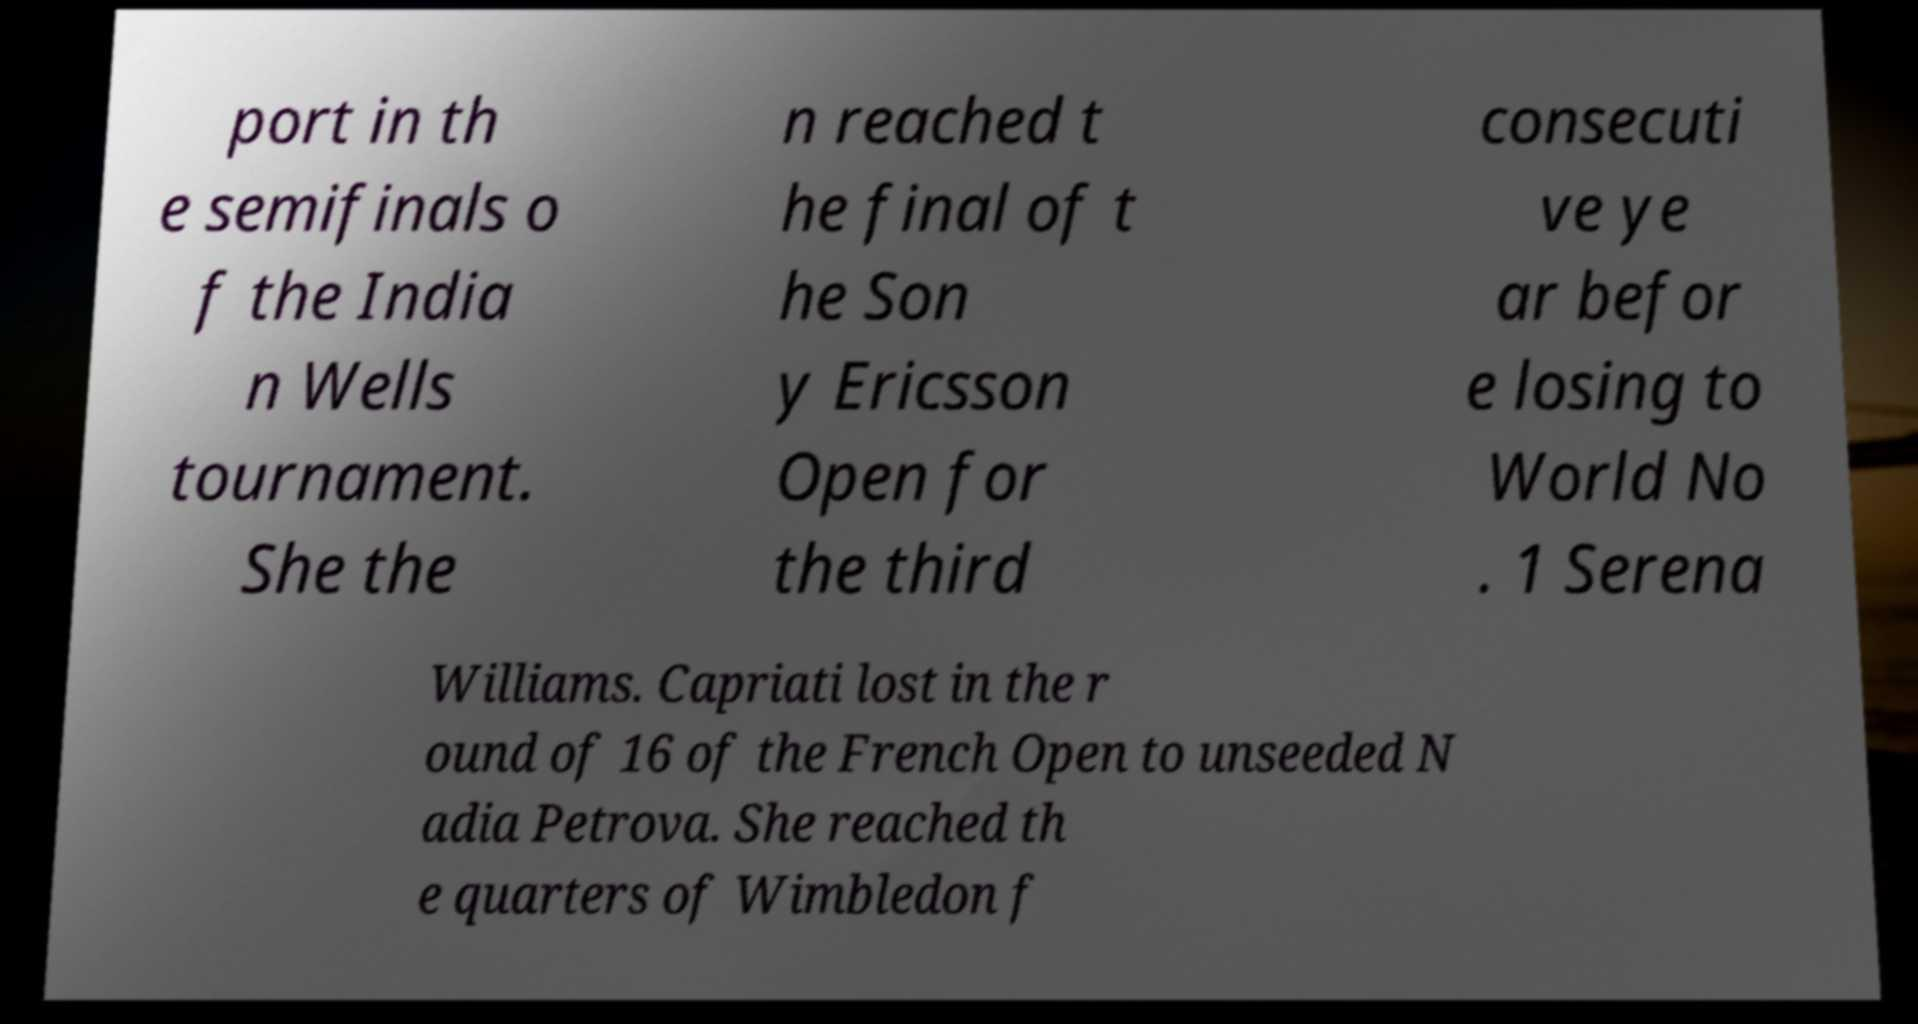Please identify and transcribe the text found in this image. port in th e semifinals o f the India n Wells tournament. She the n reached t he final of t he Son y Ericsson Open for the third consecuti ve ye ar befor e losing to World No . 1 Serena Williams. Capriati lost in the r ound of 16 of the French Open to unseeded N adia Petrova. She reached th e quarters of Wimbledon f 